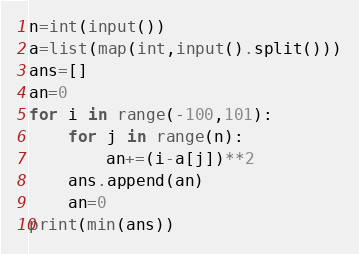Convert code to text. <code><loc_0><loc_0><loc_500><loc_500><_Python_>n=int(input())
a=list(map(int,input().split()))
ans=[]
an=0
for i in range(-100,101):
    for j in range(n):
        an+=(i-a[j])**2
    ans.append(an)
    an=0
print(min(ans))</code> 